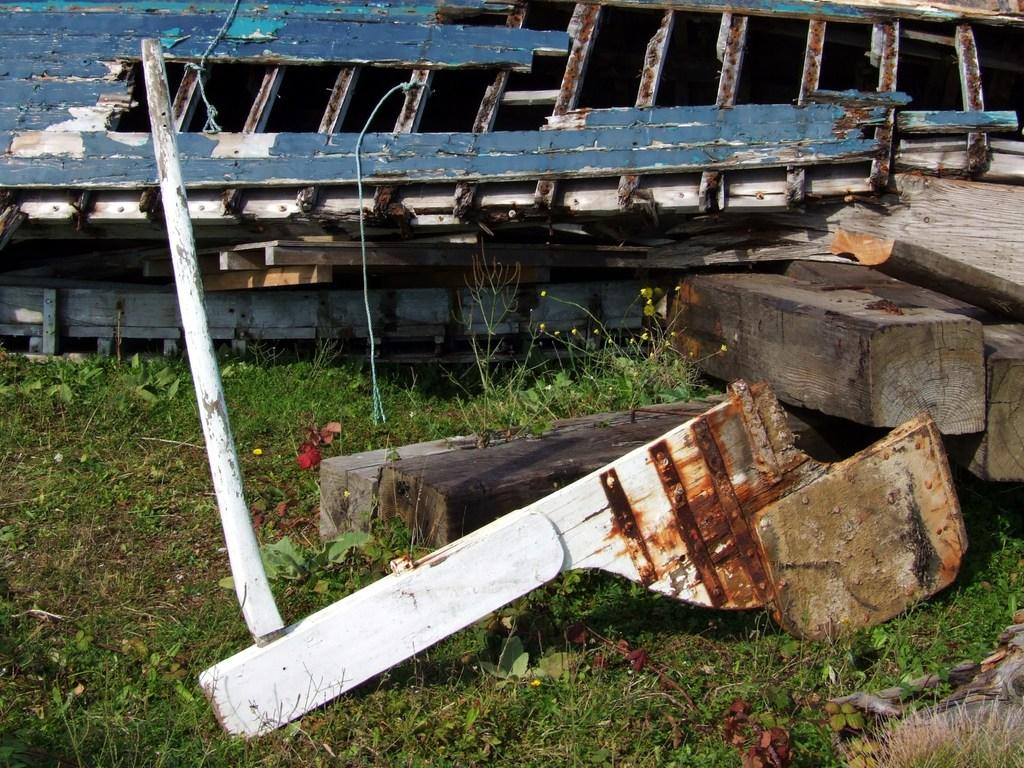What type of objects are in the foreground of the image? There are wooden objects in the foreground of the image. Where are the wooden objects located? The wooden objects are on the grass. What can be seen in the background of the image? In the background, there appears to be a wooden boat. What type of book is the person reading in the image? There is no person or book present in the image; it features wooden objects on the grass and a wooden boat in the background. 